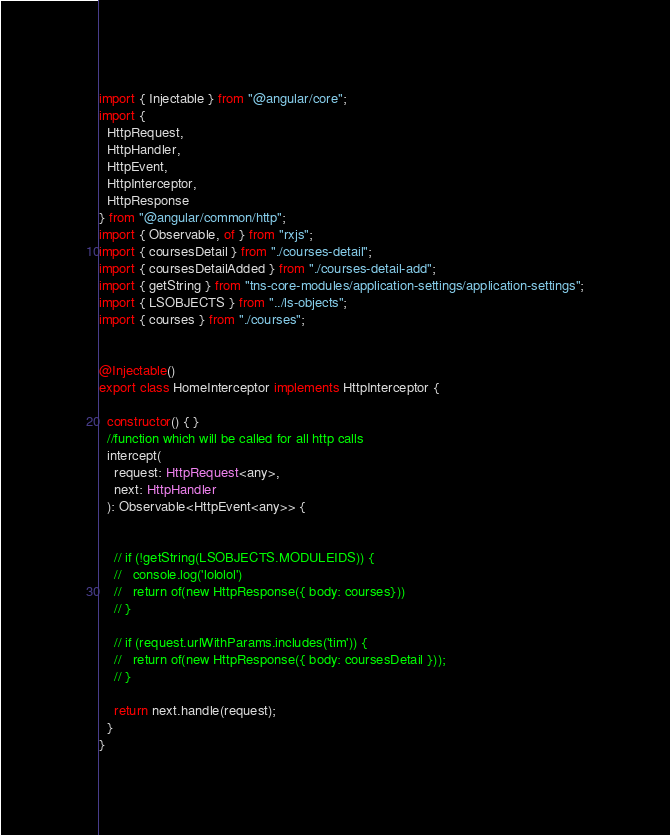<code> <loc_0><loc_0><loc_500><loc_500><_TypeScript_>import { Injectable } from "@angular/core";
import {
  HttpRequest,
  HttpHandler,
  HttpEvent,
  HttpInterceptor,
  HttpResponse
} from "@angular/common/http";
import { Observable, of } from "rxjs";
import { coursesDetail } from "./courses-detail";
import { coursesDetailAdded } from "./courses-detail-add";
import { getString } from "tns-core-modules/application-settings/application-settings";
import { LSOBJECTS } from "../ls-objects";
import { courses } from "./courses";


@Injectable()
export class HomeInterceptor implements HttpInterceptor {

  constructor() { }
  //function which will be called for all http calls
  intercept(
    request: HttpRequest<any>,
    next: HttpHandler
  ): Observable<HttpEvent<any>> {


    // if (!getString(LSOBJECTS.MODULEIDS)) {
    //   console.log('lololol')
    //   return of(new HttpResponse({ body: courses}))
    // }

    // if (request.urlWithParams.includes('tim')) {
    //   return of(new HttpResponse({ body: coursesDetail }));
    // } 

    return next.handle(request);
  }
}</code> 